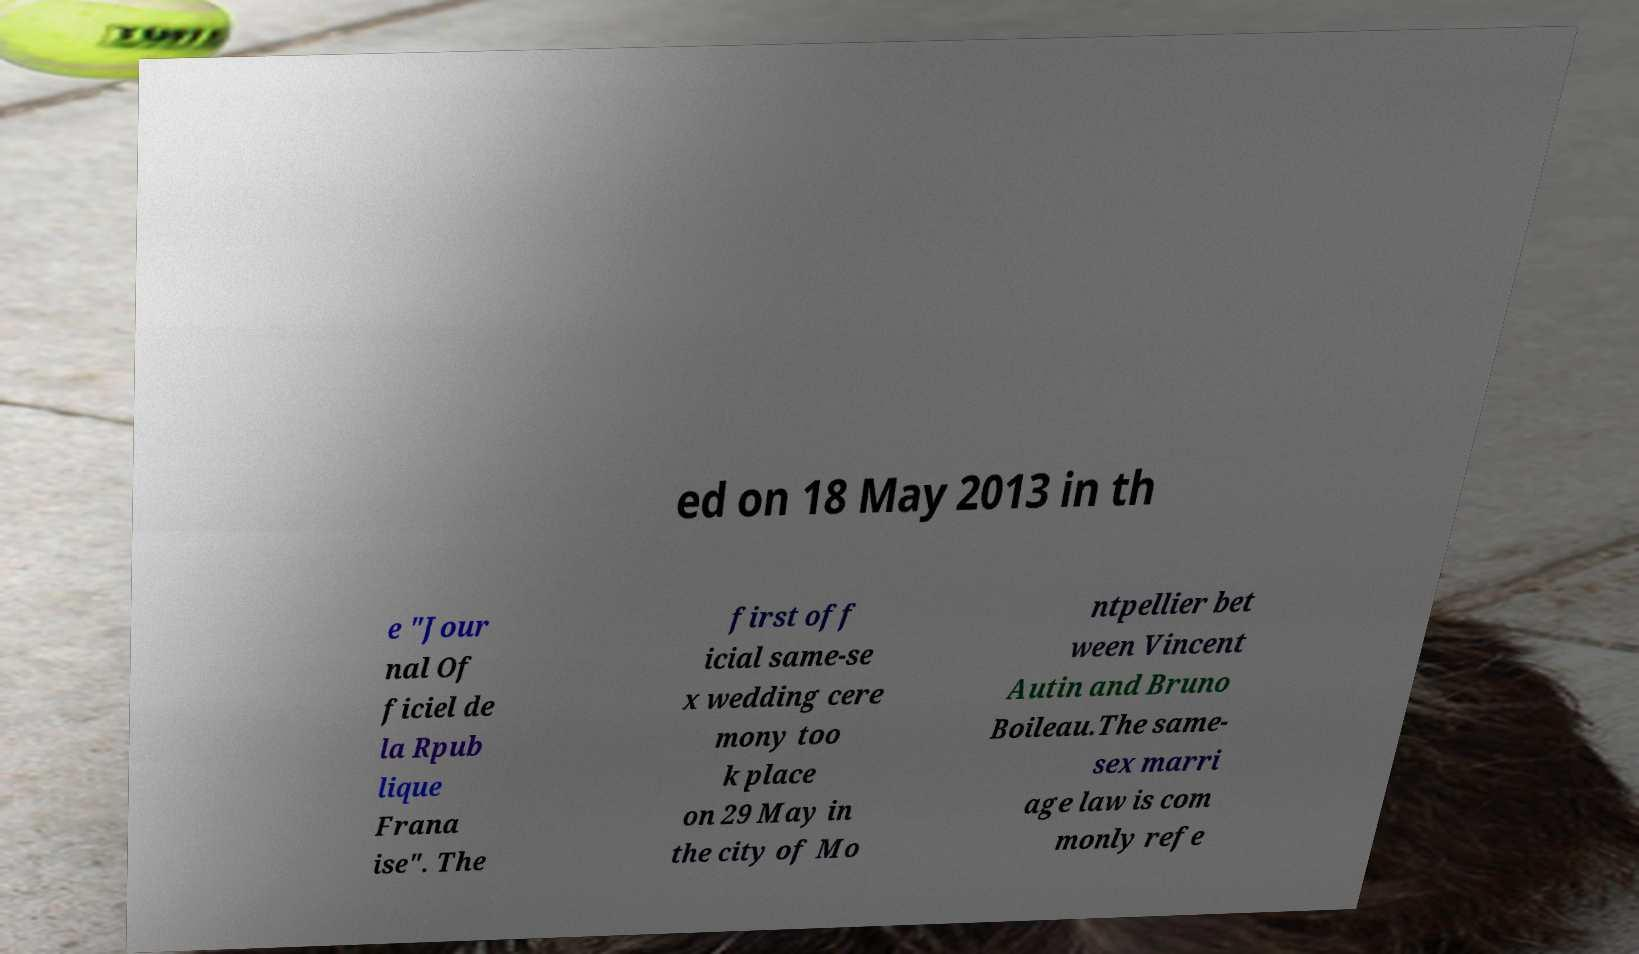Can you accurately transcribe the text from the provided image for me? ed on 18 May 2013 in th e "Jour nal Of ficiel de la Rpub lique Frana ise". The first off icial same-se x wedding cere mony too k place on 29 May in the city of Mo ntpellier bet ween Vincent Autin and Bruno Boileau.The same- sex marri age law is com monly refe 